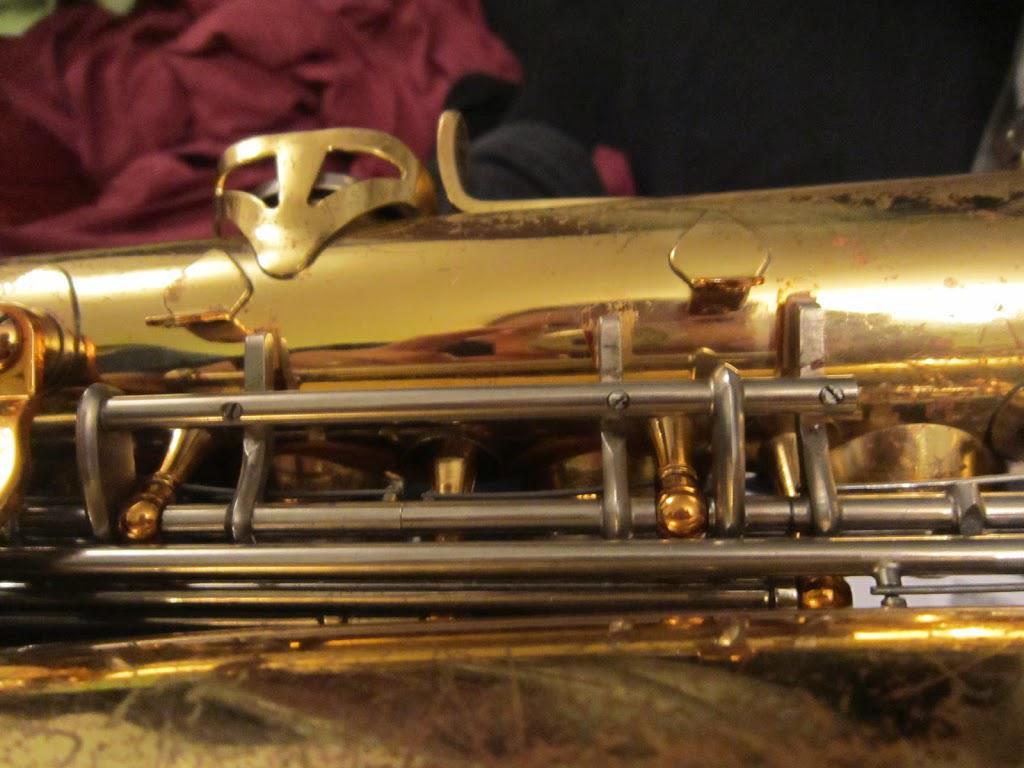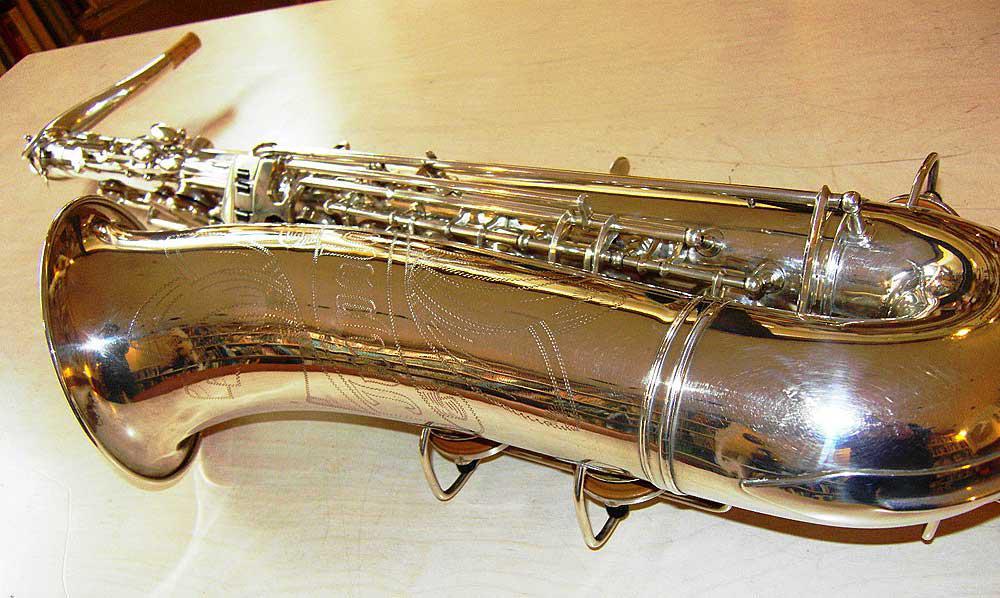The first image is the image on the left, the second image is the image on the right. Examine the images to the left and right. Is the description "The bell ends of two saxophones in different colors are lying horizontally, pointed toward the same direction." accurate? Answer yes or no. No. The first image is the image on the left, the second image is the image on the right. For the images displayed, is the sentence "Both saxophones are positioned with their bells to the right." factually correct? Answer yes or no. No. 